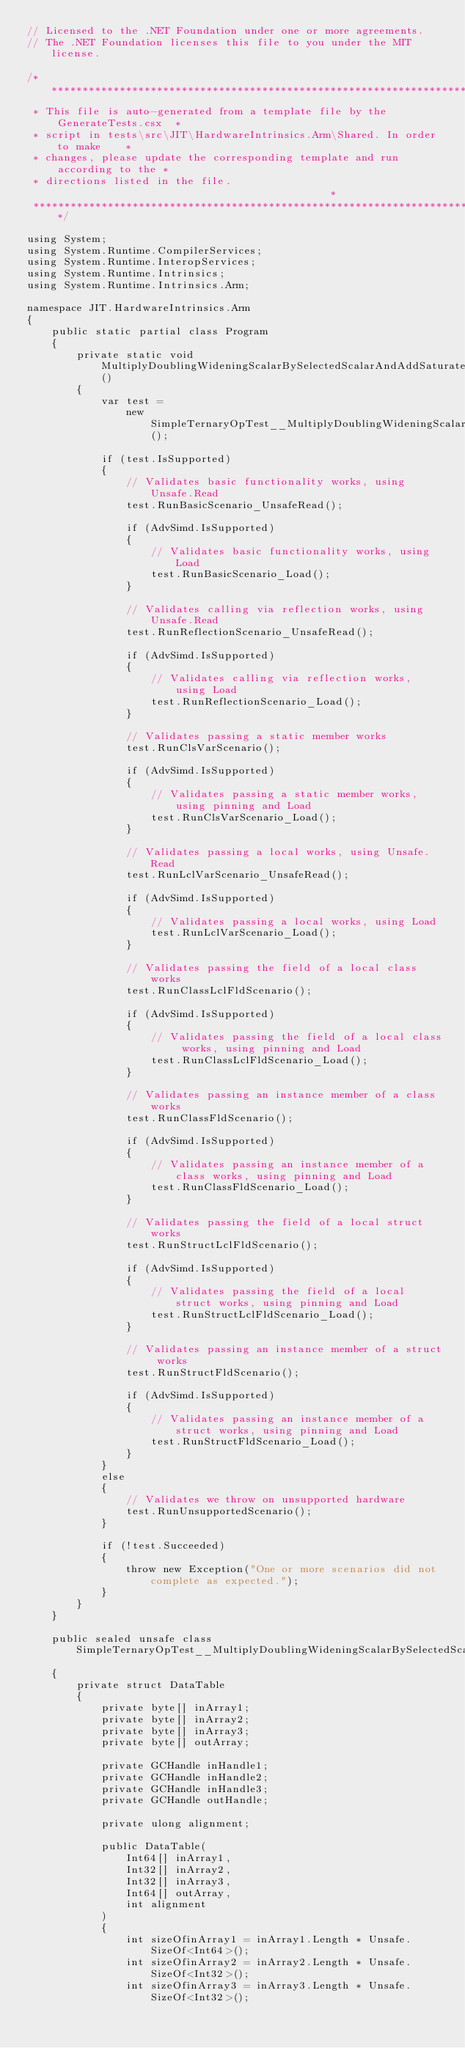Convert code to text. <code><loc_0><loc_0><loc_500><loc_500><_C#_>// Licensed to the .NET Foundation under one or more agreements.
// The .NET Foundation licenses this file to you under the MIT license.

/******************************************************************************
 * This file is auto-generated from a template file by the GenerateTests.csx  *
 * script in tests\src\JIT\HardwareIntrinsics.Arm\Shared. In order to make    *
 * changes, please update the corresponding template and run according to the *
 * directions listed in the file.                                             *
 ******************************************************************************/

using System;
using System.Runtime.CompilerServices;
using System.Runtime.InteropServices;
using System.Runtime.Intrinsics;
using System.Runtime.Intrinsics.Arm;

namespace JIT.HardwareIntrinsics.Arm
{
    public static partial class Program
    {
        private static void MultiplyDoublingWideningScalarBySelectedScalarAndAddSaturate_Vector64_Int32_Vector64_Int32_1()
        {
            var test =
                new SimpleTernaryOpTest__MultiplyDoublingWideningScalarBySelectedScalarAndAddSaturate_Vector64_Int32_Vector64_Int32_1();

            if (test.IsSupported)
            {
                // Validates basic functionality works, using Unsafe.Read
                test.RunBasicScenario_UnsafeRead();

                if (AdvSimd.IsSupported)
                {
                    // Validates basic functionality works, using Load
                    test.RunBasicScenario_Load();
                }

                // Validates calling via reflection works, using Unsafe.Read
                test.RunReflectionScenario_UnsafeRead();

                if (AdvSimd.IsSupported)
                {
                    // Validates calling via reflection works, using Load
                    test.RunReflectionScenario_Load();
                }

                // Validates passing a static member works
                test.RunClsVarScenario();

                if (AdvSimd.IsSupported)
                {
                    // Validates passing a static member works, using pinning and Load
                    test.RunClsVarScenario_Load();
                }

                // Validates passing a local works, using Unsafe.Read
                test.RunLclVarScenario_UnsafeRead();

                if (AdvSimd.IsSupported)
                {
                    // Validates passing a local works, using Load
                    test.RunLclVarScenario_Load();
                }

                // Validates passing the field of a local class works
                test.RunClassLclFldScenario();

                if (AdvSimd.IsSupported)
                {
                    // Validates passing the field of a local class works, using pinning and Load
                    test.RunClassLclFldScenario_Load();
                }

                // Validates passing an instance member of a class works
                test.RunClassFldScenario();

                if (AdvSimd.IsSupported)
                {
                    // Validates passing an instance member of a class works, using pinning and Load
                    test.RunClassFldScenario_Load();
                }

                // Validates passing the field of a local struct works
                test.RunStructLclFldScenario();

                if (AdvSimd.IsSupported)
                {
                    // Validates passing the field of a local struct works, using pinning and Load
                    test.RunStructLclFldScenario_Load();
                }

                // Validates passing an instance member of a struct works
                test.RunStructFldScenario();

                if (AdvSimd.IsSupported)
                {
                    // Validates passing an instance member of a struct works, using pinning and Load
                    test.RunStructFldScenario_Load();
                }
            }
            else
            {
                // Validates we throw on unsupported hardware
                test.RunUnsupportedScenario();
            }

            if (!test.Succeeded)
            {
                throw new Exception("One or more scenarios did not complete as expected.");
            }
        }
    }

    public sealed unsafe class SimpleTernaryOpTest__MultiplyDoublingWideningScalarBySelectedScalarAndAddSaturate_Vector64_Int32_Vector64_Int32_1
    {
        private struct DataTable
        {
            private byte[] inArray1;
            private byte[] inArray2;
            private byte[] inArray3;
            private byte[] outArray;

            private GCHandle inHandle1;
            private GCHandle inHandle2;
            private GCHandle inHandle3;
            private GCHandle outHandle;

            private ulong alignment;

            public DataTable(
                Int64[] inArray1,
                Int32[] inArray2,
                Int32[] inArray3,
                Int64[] outArray,
                int alignment
            )
            {
                int sizeOfinArray1 = inArray1.Length * Unsafe.SizeOf<Int64>();
                int sizeOfinArray2 = inArray2.Length * Unsafe.SizeOf<Int32>();
                int sizeOfinArray3 = inArray3.Length * Unsafe.SizeOf<Int32>();</code> 